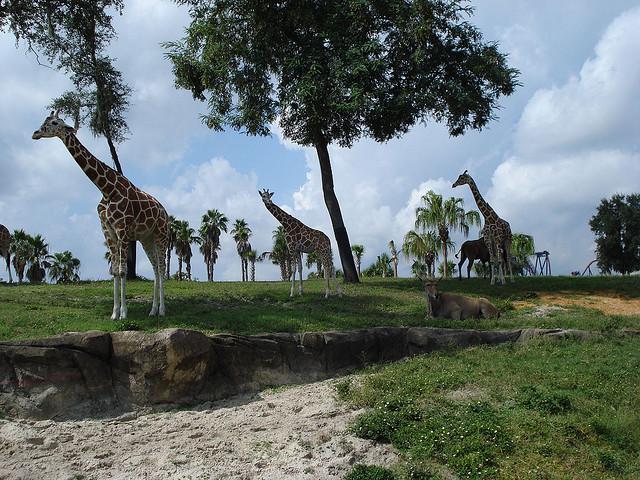Are these longhorn cattle?
Write a very short answer. No. What kind of animal do you see?
Concise answer only. Giraffe. Is there a watering hole?
Give a very brief answer. Yes. What type of tree is in the photo?
Be succinct. Acacia. Is it fall in the image?
Quick response, please. No. Is this a public park?
Be succinct. No. Is there a building in this picture?
Keep it brief. No. What type of trees are these?
Concise answer only. Tall. What animals are in the field?
Keep it brief. Giraffes. What color is the tree leaves?
Concise answer only. Green. Is there a person guiding these animals?
Answer briefly. No. Is there any water for the giraffe's?
Quick response, please. No. Is this a dense forest?
Answer briefly. No. What animal is present?
Short answer required. Giraffe. Is the rock in the trees?
Keep it brief. No. Is this a bear?
Write a very short answer. No. Is the animal standing on its hind legs?
Keep it brief. No. How many giraffe are on the grass?
Short answer required. 3. Are the animals wearing shoes?
Give a very brief answer. No. Is this in the fall?
Short answer required. No. Is it noon?
Concise answer only. Yes. How many giraffes are in the picture?
Quick response, please. 3. What animal is that?
Concise answer only. Giraffe. What kind of tree is in the picture?
Concise answer only. Palm. How many large rocks do you see?
Concise answer only. 1. What animals are shown?
Answer briefly. Giraffes. What type of animals are standing in the field?
Quick response, please. Giraffes. Does the close tree have any leaves?
Write a very short answer. Yes. Which is taller the rocks or the giraffe?
Answer briefly. Giraffe. How many giraffes are there?
Write a very short answer. 3. What kind of animal is this?
Short answer required. Giraffe. 